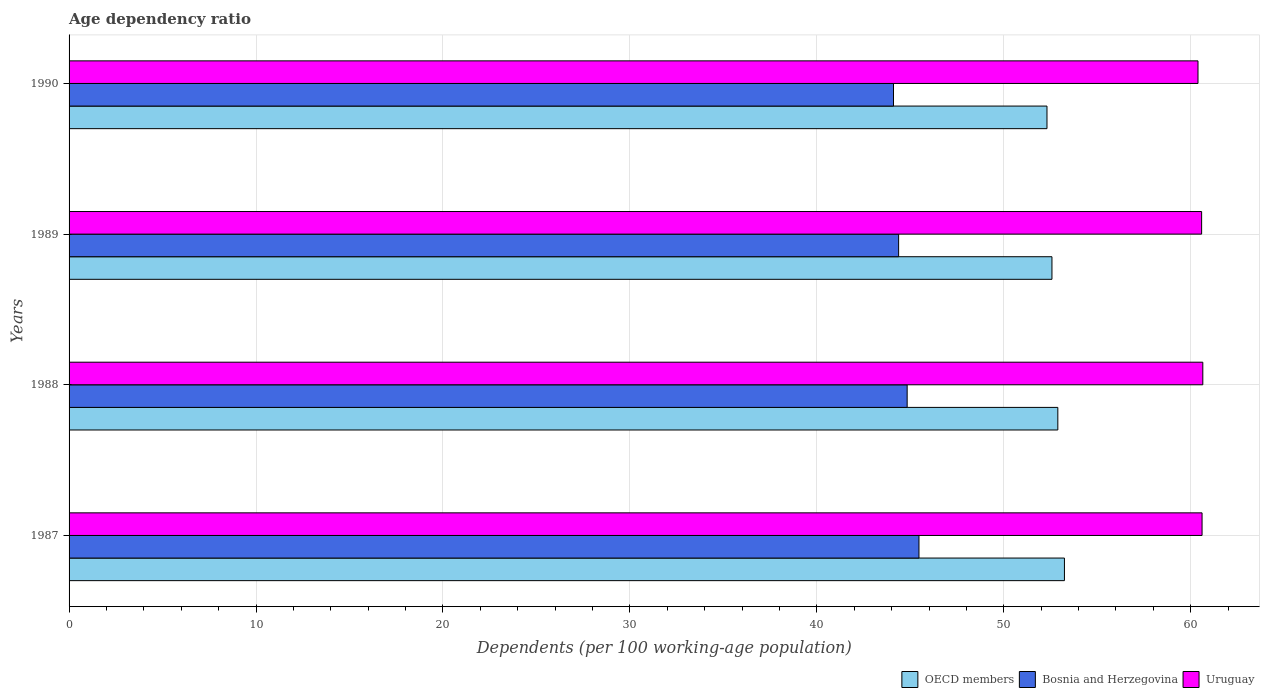Are the number of bars on each tick of the Y-axis equal?
Offer a terse response. Yes. How many bars are there on the 3rd tick from the bottom?
Your response must be concise. 3. In how many cases, is the number of bars for a given year not equal to the number of legend labels?
Give a very brief answer. 0. What is the age dependency ratio in in Uruguay in 1989?
Ensure brevity in your answer.  60.58. Across all years, what is the maximum age dependency ratio in in OECD members?
Your response must be concise. 53.24. Across all years, what is the minimum age dependency ratio in in Uruguay?
Provide a short and direct response. 60.39. In which year was the age dependency ratio in in Bosnia and Herzegovina maximum?
Your answer should be compact. 1987. What is the total age dependency ratio in in OECD members in the graph?
Offer a very short reply. 211.02. What is the difference between the age dependency ratio in in OECD members in 1987 and that in 1990?
Ensure brevity in your answer.  0.93. What is the difference between the age dependency ratio in in OECD members in 1987 and the age dependency ratio in in Uruguay in 1989?
Provide a short and direct response. -7.34. What is the average age dependency ratio in in OECD members per year?
Your answer should be compact. 52.76. In the year 1987, what is the difference between the age dependency ratio in in Uruguay and age dependency ratio in in Bosnia and Herzegovina?
Your response must be concise. 15.14. What is the ratio of the age dependency ratio in in OECD members in 1988 to that in 1989?
Ensure brevity in your answer.  1.01. What is the difference between the highest and the second highest age dependency ratio in in OECD members?
Your response must be concise. 0.35. What is the difference between the highest and the lowest age dependency ratio in in Bosnia and Herzegovina?
Give a very brief answer. 1.36. In how many years, is the age dependency ratio in in OECD members greater than the average age dependency ratio in in OECD members taken over all years?
Ensure brevity in your answer.  2. What does the 2nd bar from the top in 1988 represents?
Give a very brief answer. Bosnia and Herzegovina. What does the 3rd bar from the bottom in 1989 represents?
Offer a very short reply. Uruguay. Is it the case that in every year, the sum of the age dependency ratio in in Bosnia and Herzegovina and age dependency ratio in in Uruguay is greater than the age dependency ratio in in OECD members?
Offer a very short reply. Yes. How many bars are there?
Your response must be concise. 12. How many years are there in the graph?
Give a very brief answer. 4. What is the difference between two consecutive major ticks on the X-axis?
Make the answer very short. 10. Does the graph contain grids?
Offer a very short reply. Yes. What is the title of the graph?
Provide a short and direct response. Age dependency ratio. Does "Liberia" appear as one of the legend labels in the graph?
Your answer should be compact. No. What is the label or title of the X-axis?
Your response must be concise. Dependents (per 100 working-age population). What is the label or title of the Y-axis?
Your response must be concise. Years. What is the Dependents (per 100 working-age population) in OECD members in 1987?
Offer a very short reply. 53.24. What is the Dependents (per 100 working-age population) in Bosnia and Herzegovina in 1987?
Make the answer very short. 45.46. What is the Dependents (per 100 working-age population) in Uruguay in 1987?
Provide a succinct answer. 60.61. What is the Dependents (per 100 working-age population) of OECD members in 1988?
Provide a short and direct response. 52.89. What is the Dependents (per 100 working-age population) in Bosnia and Herzegovina in 1988?
Provide a short and direct response. 44.83. What is the Dependents (per 100 working-age population) in Uruguay in 1988?
Ensure brevity in your answer.  60.65. What is the Dependents (per 100 working-age population) in OECD members in 1989?
Offer a terse response. 52.58. What is the Dependents (per 100 working-age population) in Bosnia and Herzegovina in 1989?
Your answer should be compact. 44.37. What is the Dependents (per 100 working-age population) of Uruguay in 1989?
Your answer should be compact. 60.58. What is the Dependents (per 100 working-age population) of OECD members in 1990?
Give a very brief answer. 52.31. What is the Dependents (per 100 working-age population) of Bosnia and Herzegovina in 1990?
Offer a terse response. 44.1. What is the Dependents (per 100 working-age population) of Uruguay in 1990?
Provide a succinct answer. 60.39. Across all years, what is the maximum Dependents (per 100 working-age population) of OECD members?
Ensure brevity in your answer.  53.24. Across all years, what is the maximum Dependents (per 100 working-age population) of Bosnia and Herzegovina?
Offer a very short reply. 45.46. Across all years, what is the maximum Dependents (per 100 working-age population) in Uruguay?
Provide a short and direct response. 60.65. Across all years, what is the minimum Dependents (per 100 working-age population) in OECD members?
Provide a succinct answer. 52.31. Across all years, what is the minimum Dependents (per 100 working-age population) in Bosnia and Herzegovina?
Offer a very short reply. 44.1. Across all years, what is the minimum Dependents (per 100 working-age population) of Uruguay?
Keep it short and to the point. 60.39. What is the total Dependents (per 100 working-age population) in OECD members in the graph?
Give a very brief answer. 211.02. What is the total Dependents (per 100 working-age population) in Bosnia and Herzegovina in the graph?
Ensure brevity in your answer.  178.77. What is the total Dependents (per 100 working-age population) in Uruguay in the graph?
Make the answer very short. 242.22. What is the difference between the Dependents (per 100 working-age population) of OECD members in 1987 and that in 1988?
Your response must be concise. 0.35. What is the difference between the Dependents (per 100 working-age population) of Bosnia and Herzegovina in 1987 and that in 1988?
Your response must be concise. 0.63. What is the difference between the Dependents (per 100 working-age population) of Uruguay in 1987 and that in 1988?
Your answer should be compact. -0.04. What is the difference between the Dependents (per 100 working-age population) of OECD members in 1987 and that in 1989?
Offer a very short reply. 0.67. What is the difference between the Dependents (per 100 working-age population) in Bosnia and Herzegovina in 1987 and that in 1989?
Your response must be concise. 1.09. What is the difference between the Dependents (per 100 working-age population) in Uruguay in 1987 and that in 1989?
Keep it short and to the point. 0.02. What is the difference between the Dependents (per 100 working-age population) of OECD members in 1987 and that in 1990?
Provide a succinct answer. 0.93. What is the difference between the Dependents (per 100 working-age population) of Bosnia and Herzegovina in 1987 and that in 1990?
Your answer should be very brief. 1.36. What is the difference between the Dependents (per 100 working-age population) in Uruguay in 1987 and that in 1990?
Offer a terse response. 0.22. What is the difference between the Dependents (per 100 working-age population) of OECD members in 1988 and that in 1989?
Provide a short and direct response. 0.31. What is the difference between the Dependents (per 100 working-age population) in Bosnia and Herzegovina in 1988 and that in 1989?
Your response must be concise. 0.46. What is the difference between the Dependents (per 100 working-age population) in Uruguay in 1988 and that in 1989?
Provide a short and direct response. 0.06. What is the difference between the Dependents (per 100 working-age population) of OECD members in 1988 and that in 1990?
Provide a short and direct response. 0.58. What is the difference between the Dependents (per 100 working-age population) in Bosnia and Herzegovina in 1988 and that in 1990?
Offer a very short reply. 0.73. What is the difference between the Dependents (per 100 working-age population) of Uruguay in 1988 and that in 1990?
Offer a very short reply. 0.26. What is the difference between the Dependents (per 100 working-age population) of OECD members in 1989 and that in 1990?
Provide a succinct answer. 0.27. What is the difference between the Dependents (per 100 working-age population) in Bosnia and Herzegovina in 1989 and that in 1990?
Give a very brief answer. 0.27. What is the difference between the Dependents (per 100 working-age population) of Uruguay in 1989 and that in 1990?
Give a very brief answer. 0.19. What is the difference between the Dependents (per 100 working-age population) of OECD members in 1987 and the Dependents (per 100 working-age population) of Bosnia and Herzegovina in 1988?
Offer a terse response. 8.41. What is the difference between the Dependents (per 100 working-age population) in OECD members in 1987 and the Dependents (per 100 working-age population) in Uruguay in 1988?
Ensure brevity in your answer.  -7.4. What is the difference between the Dependents (per 100 working-age population) in Bosnia and Herzegovina in 1987 and the Dependents (per 100 working-age population) in Uruguay in 1988?
Make the answer very short. -15.18. What is the difference between the Dependents (per 100 working-age population) of OECD members in 1987 and the Dependents (per 100 working-age population) of Bosnia and Herzegovina in 1989?
Make the answer very short. 8.87. What is the difference between the Dependents (per 100 working-age population) in OECD members in 1987 and the Dependents (per 100 working-age population) in Uruguay in 1989?
Offer a terse response. -7.34. What is the difference between the Dependents (per 100 working-age population) of Bosnia and Herzegovina in 1987 and the Dependents (per 100 working-age population) of Uruguay in 1989?
Your response must be concise. -15.12. What is the difference between the Dependents (per 100 working-age population) of OECD members in 1987 and the Dependents (per 100 working-age population) of Bosnia and Herzegovina in 1990?
Your answer should be very brief. 9.14. What is the difference between the Dependents (per 100 working-age population) of OECD members in 1987 and the Dependents (per 100 working-age population) of Uruguay in 1990?
Offer a very short reply. -7.14. What is the difference between the Dependents (per 100 working-age population) of Bosnia and Herzegovina in 1987 and the Dependents (per 100 working-age population) of Uruguay in 1990?
Offer a terse response. -14.93. What is the difference between the Dependents (per 100 working-age population) in OECD members in 1988 and the Dependents (per 100 working-age population) in Bosnia and Herzegovina in 1989?
Provide a succinct answer. 8.52. What is the difference between the Dependents (per 100 working-age population) in OECD members in 1988 and the Dependents (per 100 working-age population) in Uruguay in 1989?
Make the answer very short. -7.69. What is the difference between the Dependents (per 100 working-age population) of Bosnia and Herzegovina in 1988 and the Dependents (per 100 working-age population) of Uruguay in 1989?
Provide a succinct answer. -15.75. What is the difference between the Dependents (per 100 working-age population) of OECD members in 1988 and the Dependents (per 100 working-age population) of Bosnia and Herzegovina in 1990?
Your response must be concise. 8.79. What is the difference between the Dependents (per 100 working-age population) in OECD members in 1988 and the Dependents (per 100 working-age population) in Uruguay in 1990?
Offer a terse response. -7.5. What is the difference between the Dependents (per 100 working-age population) in Bosnia and Herzegovina in 1988 and the Dependents (per 100 working-age population) in Uruguay in 1990?
Your response must be concise. -15.56. What is the difference between the Dependents (per 100 working-age population) of OECD members in 1989 and the Dependents (per 100 working-age population) of Bosnia and Herzegovina in 1990?
Your answer should be compact. 8.48. What is the difference between the Dependents (per 100 working-age population) of OECD members in 1989 and the Dependents (per 100 working-age population) of Uruguay in 1990?
Make the answer very short. -7.81. What is the difference between the Dependents (per 100 working-age population) in Bosnia and Herzegovina in 1989 and the Dependents (per 100 working-age population) in Uruguay in 1990?
Ensure brevity in your answer.  -16.01. What is the average Dependents (per 100 working-age population) in OECD members per year?
Your answer should be compact. 52.76. What is the average Dependents (per 100 working-age population) of Bosnia and Herzegovina per year?
Keep it short and to the point. 44.69. What is the average Dependents (per 100 working-age population) of Uruguay per year?
Ensure brevity in your answer.  60.56. In the year 1987, what is the difference between the Dependents (per 100 working-age population) in OECD members and Dependents (per 100 working-age population) in Bosnia and Herzegovina?
Your answer should be very brief. 7.78. In the year 1987, what is the difference between the Dependents (per 100 working-age population) of OECD members and Dependents (per 100 working-age population) of Uruguay?
Provide a succinct answer. -7.36. In the year 1987, what is the difference between the Dependents (per 100 working-age population) of Bosnia and Herzegovina and Dependents (per 100 working-age population) of Uruguay?
Your answer should be compact. -15.14. In the year 1988, what is the difference between the Dependents (per 100 working-age population) of OECD members and Dependents (per 100 working-age population) of Bosnia and Herzegovina?
Your response must be concise. 8.06. In the year 1988, what is the difference between the Dependents (per 100 working-age population) in OECD members and Dependents (per 100 working-age population) in Uruguay?
Your answer should be very brief. -7.76. In the year 1988, what is the difference between the Dependents (per 100 working-age population) of Bosnia and Herzegovina and Dependents (per 100 working-age population) of Uruguay?
Ensure brevity in your answer.  -15.81. In the year 1989, what is the difference between the Dependents (per 100 working-age population) in OECD members and Dependents (per 100 working-age population) in Bosnia and Herzegovina?
Give a very brief answer. 8.2. In the year 1989, what is the difference between the Dependents (per 100 working-age population) in OECD members and Dependents (per 100 working-age population) in Uruguay?
Provide a succinct answer. -8.01. In the year 1989, what is the difference between the Dependents (per 100 working-age population) in Bosnia and Herzegovina and Dependents (per 100 working-age population) in Uruguay?
Make the answer very short. -16.21. In the year 1990, what is the difference between the Dependents (per 100 working-age population) in OECD members and Dependents (per 100 working-age population) in Bosnia and Herzegovina?
Your response must be concise. 8.21. In the year 1990, what is the difference between the Dependents (per 100 working-age population) of OECD members and Dependents (per 100 working-age population) of Uruguay?
Keep it short and to the point. -8.08. In the year 1990, what is the difference between the Dependents (per 100 working-age population) in Bosnia and Herzegovina and Dependents (per 100 working-age population) in Uruguay?
Give a very brief answer. -16.29. What is the ratio of the Dependents (per 100 working-age population) of Bosnia and Herzegovina in 1987 to that in 1988?
Give a very brief answer. 1.01. What is the ratio of the Dependents (per 100 working-age population) of Uruguay in 1987 to that in 1988?
Your answer should be very brief. 1. What is the ratio of the Dependents (per 100 working-age population) in OECD members in 1987 to that in 1989?
Ensure brevity in your answer.  1.01. What is the ratio of the Dependents (per 100 working-age population) in Bosnia and Herzegovina in 1987 to that in 1989?
Your answer should be compact. 1.02. What is the ratio of the Dependents (per 100 working-age population) in Uruguay in 1987 to that in 1989?
Keep it short and to the point. 1. What is the ratio of the Dependents (per 100 working-age population) in OECD members in 1987 to that in 1990?
Provide a succinct answer. 1.02. What is the ratio of the Dependents (per 100 working-age population) of Bosnia and Herzegovina in 1987 to that in 1990?
Make the answer very short. 1.03. What is the ratio of the Dependents (per 100 working-age population) in Uruguay in 1987 to that in 1990?
Ensure brevity in your answer.  1. What is the ratio of the Dependents (per 100 working-age population) of Bosnia and Herzegovina in 1988 to that in 1989?
Your response must be concise. 1.01. What is the ratio of the Dependents (per 100 working-age population) of Uruguay in 1988 to that in 1989?
Your answer should be very brief. 1. What is the ratio of the Dependents (per 100 working-age population) in OECD members in 1988 to that in 1990?
Your answer should be very brief. 1.01. What is the ratio of the Dependents (per 100 working-age population) of Bosnia and Herzegovina in 1988 to that in 1990?
Provide a short and direct response. 1.02. What is the ratio of the Dependents (per 100 working-age population) in Uruguay in 1988 to that in 1990?
Give a very brief answer. 1. What is the ratio of the Dependents (per 100 working-age population) of OECD members in 1989 to that in 1990?
Offer a very short reply. 1.01. What is the ratio of the Dependents (per 100 working-age population) of Uruguay in 1989 to that in 1990?
Your response must be concise. 1. What is the difference between the highest and the second highest Dependents (per 100 working-age population) in OECD members?
Offer a terse response. 0.35. What is the difference between the highest and the second highest Dependents (per 100 working-age population) of Bosnia and Herzegovina?
Provide a succinct answer. 0.63. What is the difference between the highest and the second highest Dependents (per 100 working-age population) in Uruguay?
Your response must be concise. 0.04. What is the difference between the highest and the lowest Dependents (per 100 working-age population) of OECD members?
Your answer should be very brief. 0.93. What is the difference between the highest and the lowest Dependents (per 100 working-age population) of Bosnia and Herzegovina?
Your answer should be very brief. 1.36. What is the difference between the highest and the lowest Dependents (per 100 working-age population) of Uruguay?
Provide a succinct answer. 0.26. 